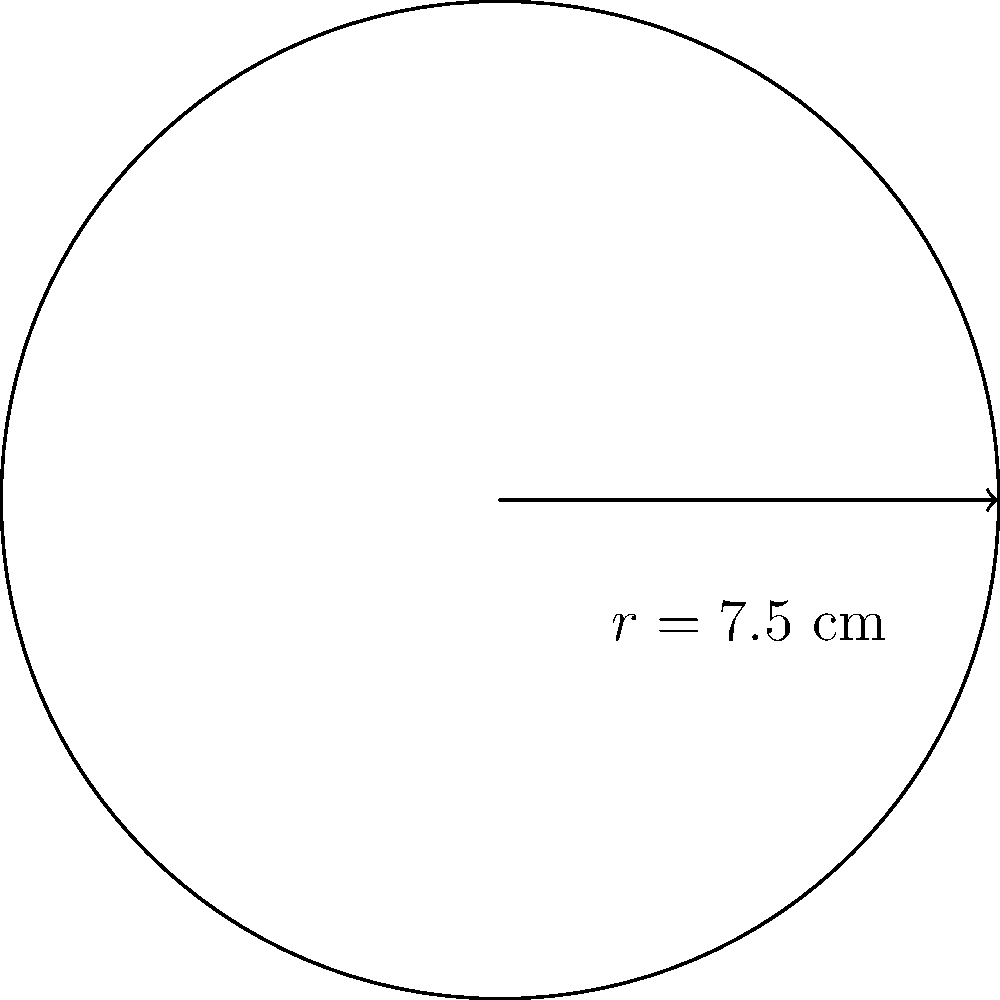As a materials procurement specialist, you need to order a circular sheet of material for a new machine part. The machine operator has specified that the sheet should have a radius of 7.5 cm. Calculate the area of this circular material sheet to ensure you order the correct amount. Use $\pi = 3.14$ for your calculations. To calculate the area of a circular sheet, we use the formula:

$$A = \pi r^2$$

Where:
$A$ = Area of the circle
$\pi$ = Pi (given as 3.14)
$r$ = Radius of the circle

Step 1: Identify the given values
$r = 7.5$ cm
$\pi = 3.14$

Step 2: Substitute the values into the formula
$$A = 3.14 \times (7.5\text{ cm})^2$$

Step 3: Calculate the square of the radius
$$(7.5\text{ cm})^2 = 56.25\text{ cm}^2$$

Step 4: Multiply by $\pi$
$$A = 3.14 \times 56.25\text{ cm}^2 = 176.625\text{ cm}^2$$

Step 5: Round to two decimal places
$$A \approx 176.63\text{ cm}^2$$
Answer: $176.63\text{ cm}^2$ 